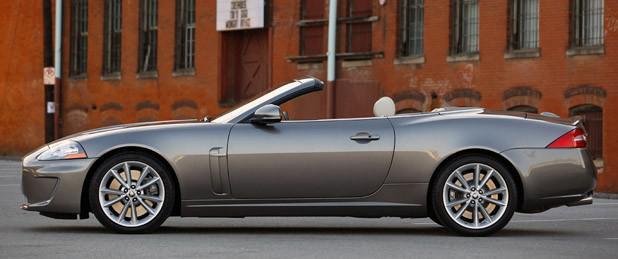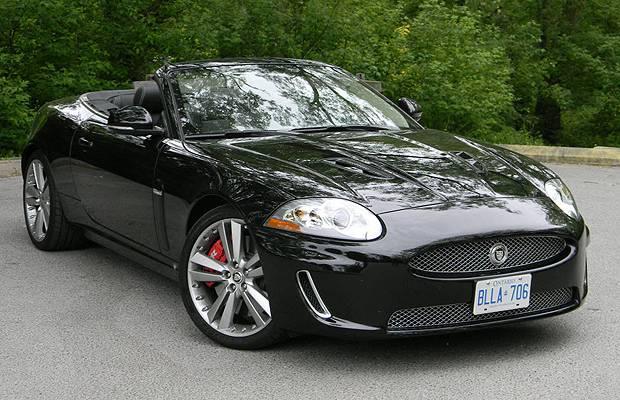The first image is the image on the left, the second image is the image on the right. For the images shown, is this caption "There is a black convertible on a paved street with its top down" true? Answer yes or no. Yes. The first image is the image on the left, the second image is the image on the right. Given the left and right images, does the statement "there are solid white convertibles" hold true? Answer yes or no. No. 